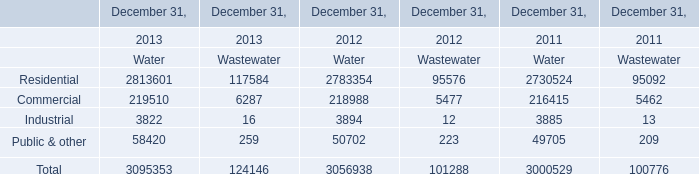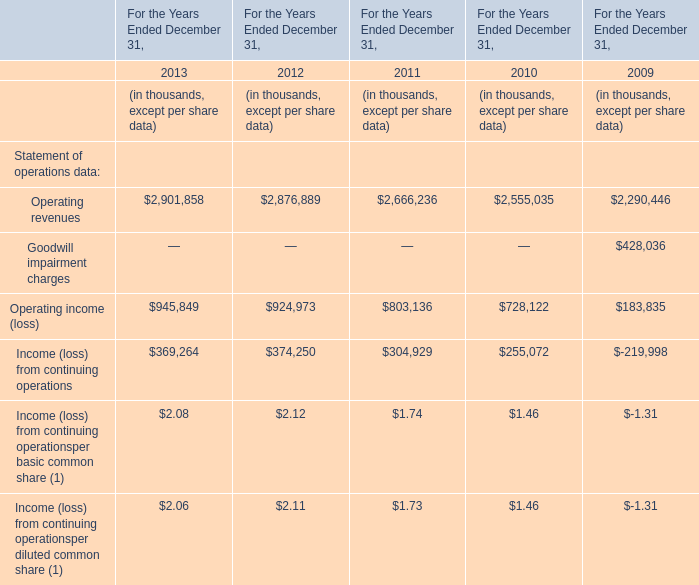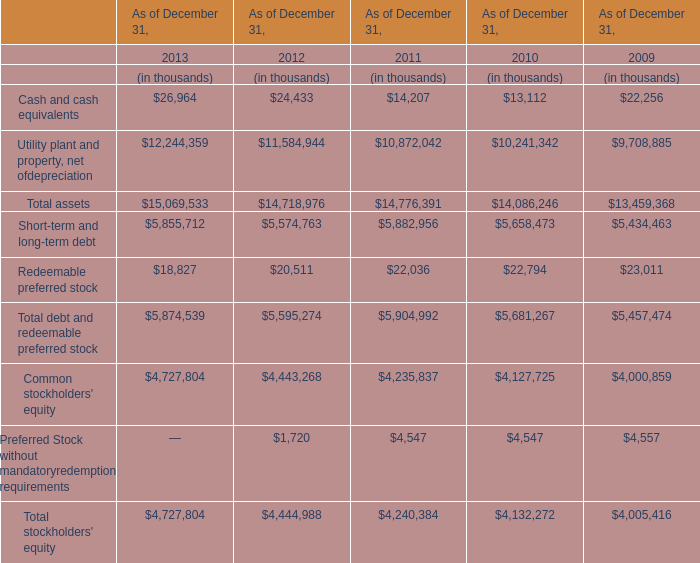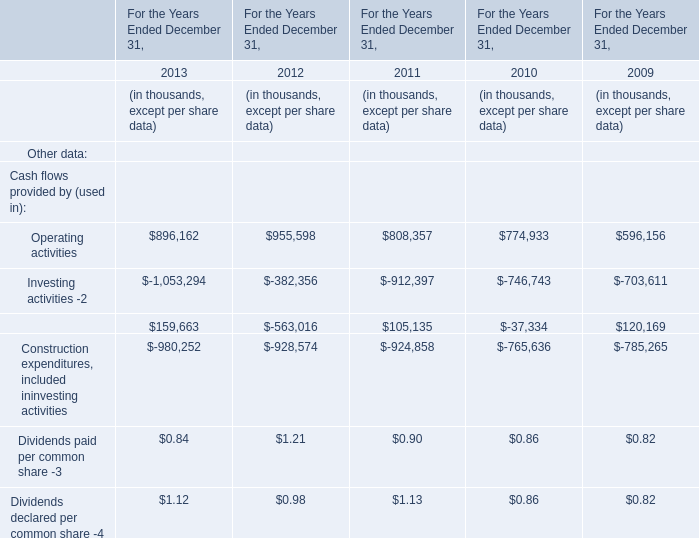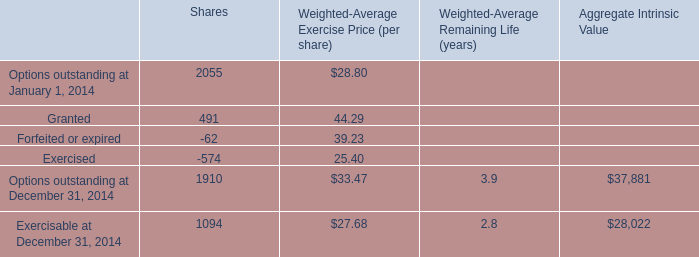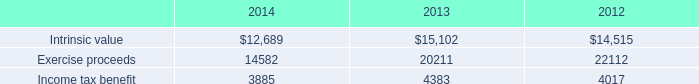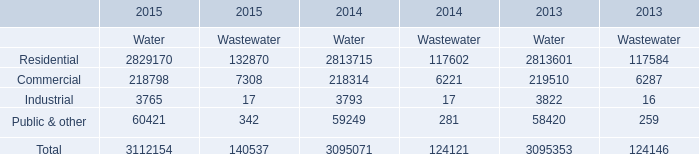What's the average of Utility plant and property, net of depreciation and Utility plant and property, net of depreciation in 2013? 
Computations: ((26964 + 12244359) / 2)
Answer: 6135661.5. 